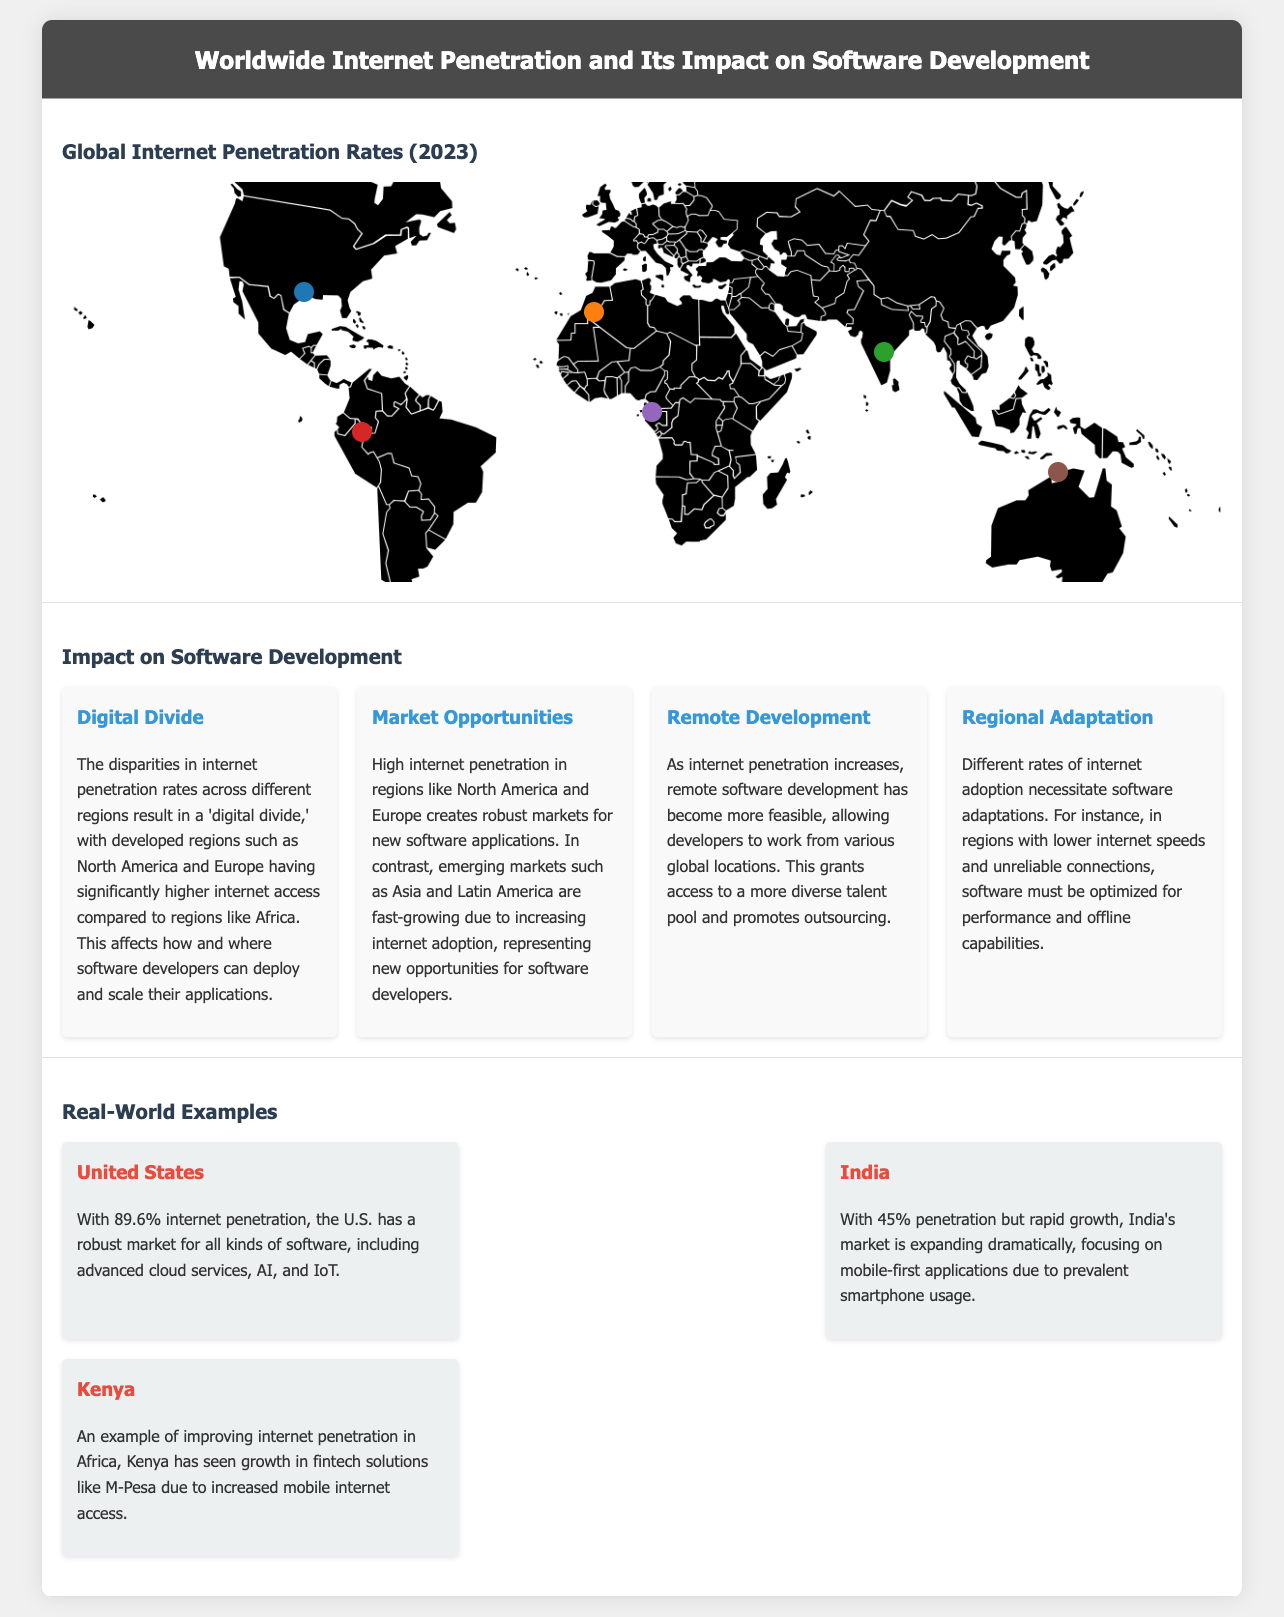What is the internet penetration rate in North America? The document states that North America has an internet penetration rate of 89.6%.
Answer: 89.6% What region has the lowest internet penetration rate according to the infographic? The infographic shows that Africa has the lowest internet penetration rate at 43.0%.
Answer: Africa What percentage of internet penetration does Asia have? The document lists that Asia has a penetration rate of 63.2%.
Answer: 63.2% What impact does high internet penetration in developed regions have on software development? High internet penetration creates robust markets for new software applications, particularly in North America and Europe.
Answer: Robust markets Which country is highlighted as having 89.6% internet penetration? The document mentions the United States has an internet penetration rate of 89.6%.
Answer: United States What is a significant benefit of increasing internet penetration for software developers? Increased internet penetration allows remote software development, granting access to a more diverse talent pool.
Answer: Remote development How does low internet penetration affect software adaptation? The document states that lower internet speeds necessitate optimizations for performance and offline capabilities.
Answer: Optimizations Which country is recognized for its rapid growth in internet penetration and mobile-first applications? The document highlights India as the country experiencing rapid growth with a focus on mobile-first applications.
Answer: India 